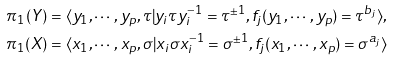<formula> <loc_0><loc_0><loc_500><loc_500>\pi _ { 1 } ( Y ) & = \langle y _ { 1 } , \cdots , y _ { p } , \tau | y _ { i } { \tau } y _ { i } ^ { - 1 } = { \tau } ^ { \pm 1 } , f _ { j } ( y _ { 1 } , \cdots , y _ { p } ) = \tau ^ { b _ { j } } \rangle , \\ \pi _ { 1 } ( X ) & = \langle x _ { 1 } , \cdots , x _ { p } , \sigma | x _ { i } { \sigma } x _ { i } ^ { - 1 } = { \sigma } ^ { \pm 1 } , f _ { j } ( x _ { 1 } , \cdots , x _ { p } ) = \sigma ^ { a _ { j } } \rangle</formula> 